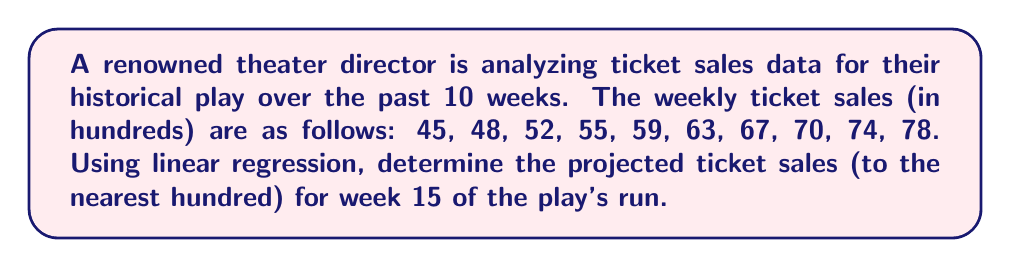Could you help me with this problem? To solve this problem using linear regression, we'll follow these steps:

1. Set up the linear regression equation:
   $y = mx + b$, where $y$ is the ticket sales, $x$ is the week number, $m$ is the slope, and $b$ is the y-intercept.

2. Calculate the means of $x$ and $y$:
   $\bar{x} = \frac{1 + 2 + 3 + ... + 10}{10} = 5.5$
   $\bar{y} = \frac{45 + 48 + 52 + ... + 78}{10} = 61.1$

3. Calculate the slope $m$ using the formula:
   $$m = \frac{\sum_{i=1}^{n} (x_i - \bar{x})(y_i - \bar{y})}{\sum_{i=1}^{n} (x_i - \bar{x})^2}$$

4. Compute the numerator and denominator:
   Numerator: $(1-5.5)(45-61.1) + (2-5.5)(48-61.1) + ... + (10-5.5)(78-61.1) = 412.5$
   Denominator: $(1-5.5)^2 + (2-5.5)^2 + ... + (10-5.5)^2 = 82.5$

5. Calculate $m$:
   $m = \frac{412.5}{82.5} = 5$

6. Calculate the y-intercept $b$ using the formula:
   $b = \bar{y} - m\bar{x} = 61.1 - 5(5.5) = 33.6$

7. The linear regression equation is:
   $y = 5x + 33.6$

8. To project ticket sales for week 15, substitute $x = 15$:
   $y = 5(15) + 33.6 = 108.6$

9. Rounding to the nearest hundred:
   108.6 hundreds ≈ 10,900 tickets
Answer: 10,900 tickets 